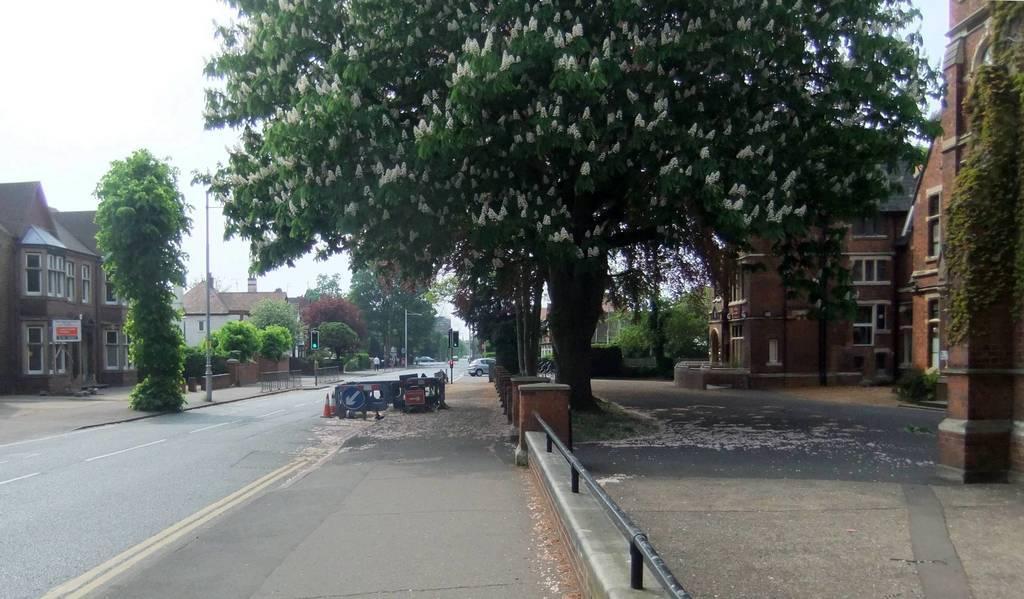Can you describe this image briefly? In this image at the bottom, there is a road. On the right there are buildings, trees. On the left there are buildings, trees, street lights, poles, traffic signals, some people, cars and sky. 